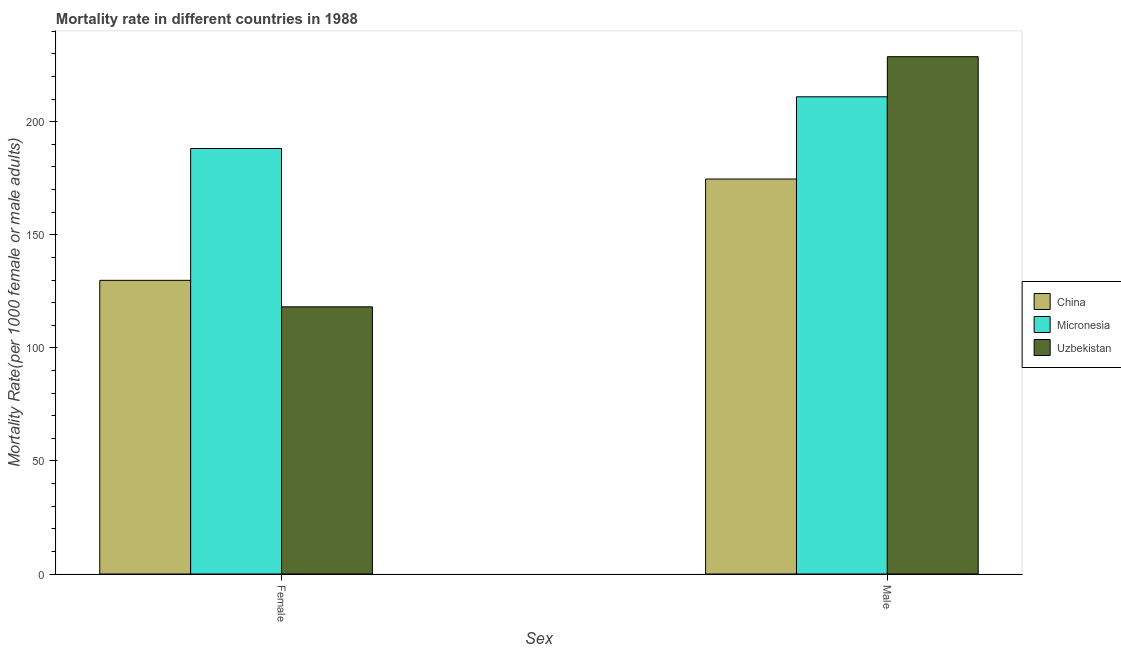How many groups of bars are there?
Offer a very short reply. 2. Are the number of bars per tick equal to the number of legend labels?
Provide a succinct answer. Yes. Are the number of bars on each tick of the X-axis equal?
Provide a short and direct response. Yes. How many bars are there on the 1st tick from the left?
Ensure brevity in your answer.  3. How many bars are there on the 1st tick from the right?
Give a very brief answer. 3. What is the label of the 1st group of bars from the left?
Your response must be concise. Female. What is the female mortality rate in China?
Offer a terse response. 129.85. Across all countries, what is the maximum female mortality rate?
Ensure brevity in your answer.  188.15. Across all countries, what is the minimum female mortality rate?
Your answer should be compact. 118.15. In which country was the female mortality rate maximum?
Keep it short and to the point. Micronesia. In which country was the male mortality rate minimum?
Your answer should be very brief. China. What is the total male mortality rate in the graph?
Your answer should be compact. 614.42. What is the difference between the male mortality rate in Micronesia and that in Uzbekistan?
Keep it short and to the point. -17.73. What is the difference between the male mortality rate in Micronesia and the female mortality rate in Uzbekistan?
Your answer should be compact. 92.87. What is the average female mortality rate per country?
Make the answer very short. 145.38. What is the difference between the female mortality rate and male mortality rate in Uzbekistan?
Give a very brief answer. -110.6. What is the ratio of the male mortality rate in Micronesia to that in Uzbekistan?
Your answer should be compact. 0.92. Is the female mortality rate in Micronesia less than that in China?
Your answer should be compact. No. In how many countries, is the male mortality rate greater than the average male mortality rate taken over all countries?
Offer a terse response. 2. What does the 1st bar from the left in Female represents?
Provide a short and direct response. China. What is the difference between two consecutive major ticks on the Y-axis?
Provide a succinct answer. 50. Are the values on the major ticks of Y-axis written in scientific E-notation?
Your answer should be very brief. No. Does the graph contain any zero values?
Your answer should be very brief. No. What is the title of the graph?
Make the answer very short. Mortality rate in different countries in 1988. What is the label or title of the X-axis?
Your answer should be very brief. Sex. What is the label or title of the Y-axis?
Provide a short and direct response. Mortality Rate(per 1000 female or male adults). What is the Mortality Rate(per 1000 female or male adults) of China in Female?
Your answer should be very brief. 129.85. What is the Mortality Rate(per 1000 female or male adults) of Micronesia in Female?
Ensure brevity in your answer.  188.15. What is the Mortality Rate(per 1000 female or male adults) of Uzbekistan in Female?
Offer a very short reply. 118.15. What is the Mortality Rate(per 1000 female or male adults) of China in Male?
Keep it short and to the point. 174.66. What is the Mortality Rate(per 1000 female or male adults) in Micronesia in Male?
Your answer should be very brief. 211.02. What is the Mortality Rate(per 1000 female or male adults) of Uzbekistan in Male?
Offer a terse response. 228.75. Across all Sex, what is the maximum Mortality Rate(per 1000 female or male adults) of China?
Make the answer very short. 174.66. Across all Sex, what is the maximum Mortality Rate(per 1000 female or male adults) in Micronesia?
Offer a very short reply. 211.02. Across all Sex, what is the maximum Mortality Rate(per 1000 female or male adults) of Uzbekistan?
Provide a succinct answer. 228.75. Across all Sex, what is the minimum Mortality Rate(per 1000 female or male adults) of China?
Keep it short and to the point. 129.85. Across all Sex, what is the minimum Mortality Rate(per 1000 female or male adults) in Micronesia?
Offer a very short reply. 188.15. Across all Sex, what is the minimum Mortality Rate(per 1000 female or male adults) of Uzbekistan?
Your answer should be very brief. 118.15. What is the total Mortality Rate(per 1000 female or male adults) in China in the graph?
Offer a terse response. 304.51. What is the total Mortality Rate(per 1000 female or male adults) of Micronesia in the graph?
Provide a short and direct response. 399.17. What is the total Mortality Rate(per 1000 female or male adults) in Uzbekistan in the graph?
Provide a succinct answer. 346.89. What is the difference between the Mortality Rate(per 1000 female or male adults) in China in Female and that in Male?
Make the answer very short. -44.81. What is the difference between the Mortality Rate(per 1000 female or male adults) of Micronesia in Female and that in Male?
Offer a terse response. -22.86. What is the difference between the Mortality Rate(per 1000 female or male adults) of Uzbekistan in Female and that in Male?
Make the answer very short. -110.6. What is the difference between the Mortality Rate(per 1000 female or male adults) in China in Female and the Mortality Rate(per 1000 female or male adults) in Micronesia in Male?
Your response must be concise. -81.16. What is the difference between the Mortality Rate(per 1000 female or male adults) of China in Female and the Mortality Rate(per 1000 female or male adults) of Uzbekistan in Male?
Your answer should be compact. -98.9. What is the difference between the Mortality Rate(per 1000 female or male adults) in Micronesia in Female and the Mortality Rate(per 1000 female or male adults) in Uzbekistan in Male?
Keep it short and to the point. -40.59. What is the average Mortality Rate(per 1000 female or male adults) in China per Sex?
Your answer should be compact. 152.26. What is the average Mortality Rate(per 1000 female or male adults) of Micronesia per Sex?
Ensure brevity in your answer.  199.58. What is the average Mortality Rate(per 1000 female or male adults) of Uzbekistan per Sex?
Ensure brevity in your answer.  173.45. What is the difference between the Mortality Rate(per 1000 female or male adults) in China and Mortality Rate(per 1000 female or male adults) in Micronesia in Female?
Offer a terse response. -58.3. What is the difference between the Mortality Rate(per 1000 female or male adults) of China and Mortality Rate(per 1000 female or male adults) of Uzbekistan in Female?
Your answer should be compact. 11.71. What is the difference between the Mortality Rate(per 1000 female or male adults) in Micronesia and Mortality Rate(per 1000 female or male adults) in Uzbekistan in Female?
Make the answer very short. 70.01. What is the difference between the Mortality Rate(per 1000 female or male adults) of China and Mortality Rate(per 1000 female or male adults) of Micronesia in Male?
Keep it short and to the point. -36.36. What is the difference between the Mortality Rate(per 1000 female or male adults) in China and Mortality Rate(per 1000 female or male adults) in Uzbekistan in Male?
Your answer should be compact. -54.09. What is the difference between the Mortality Rate(per 1000 female or male adults) of Micronesia and Mortality Rate(per 1000 female or male adults) of Uzbekistan in Male?
Give a very brief answer. -17.73. What is the ratio of the Mortality Rate(per 1000 female or male adults) in China in Female to that in Male?
Your answer should be compact. 0.74. What is the ratio of the Mortality Rate(per 1000 female or male adults) in Micronesia in Female to that in Male?
Offer a terse response. 0.89. What is the ratio of the Mortality Rate(per 1000 female or male adults) of Uzbekistan in Female to that in Male?
Your answer should be very brief. 0.52. What is the difference between the highest and the second highest Mortality Rate(per 1000 female or male adults) of China?
Give a very brief answer. 44.81. What is the difference between the highest and the second highest Mortality Rate(per 1000 female or male adults) of Micronesia?
Offer a terse response. 22.86. What is the difference between the highest and the second highest Mortality Rate(per 1000 female or male adults) in Uzbekistan?
Make the answer very short. 110.6. What is the difference between the highest and the lowest Mortality Rate(per 1000 female or male adults) in China?
Make the answer very short. 44.81. What is the difference between the highest and the lowest Mortality Rate(per 1000 female or male adults) of Micronesia?
Your answer should be compact. 22.86. What is the difference between the highest and the lowest Mortality Rate(per 1000 female or male adults) in Uzbekistan?
Your answer should be compact. 110.6. 